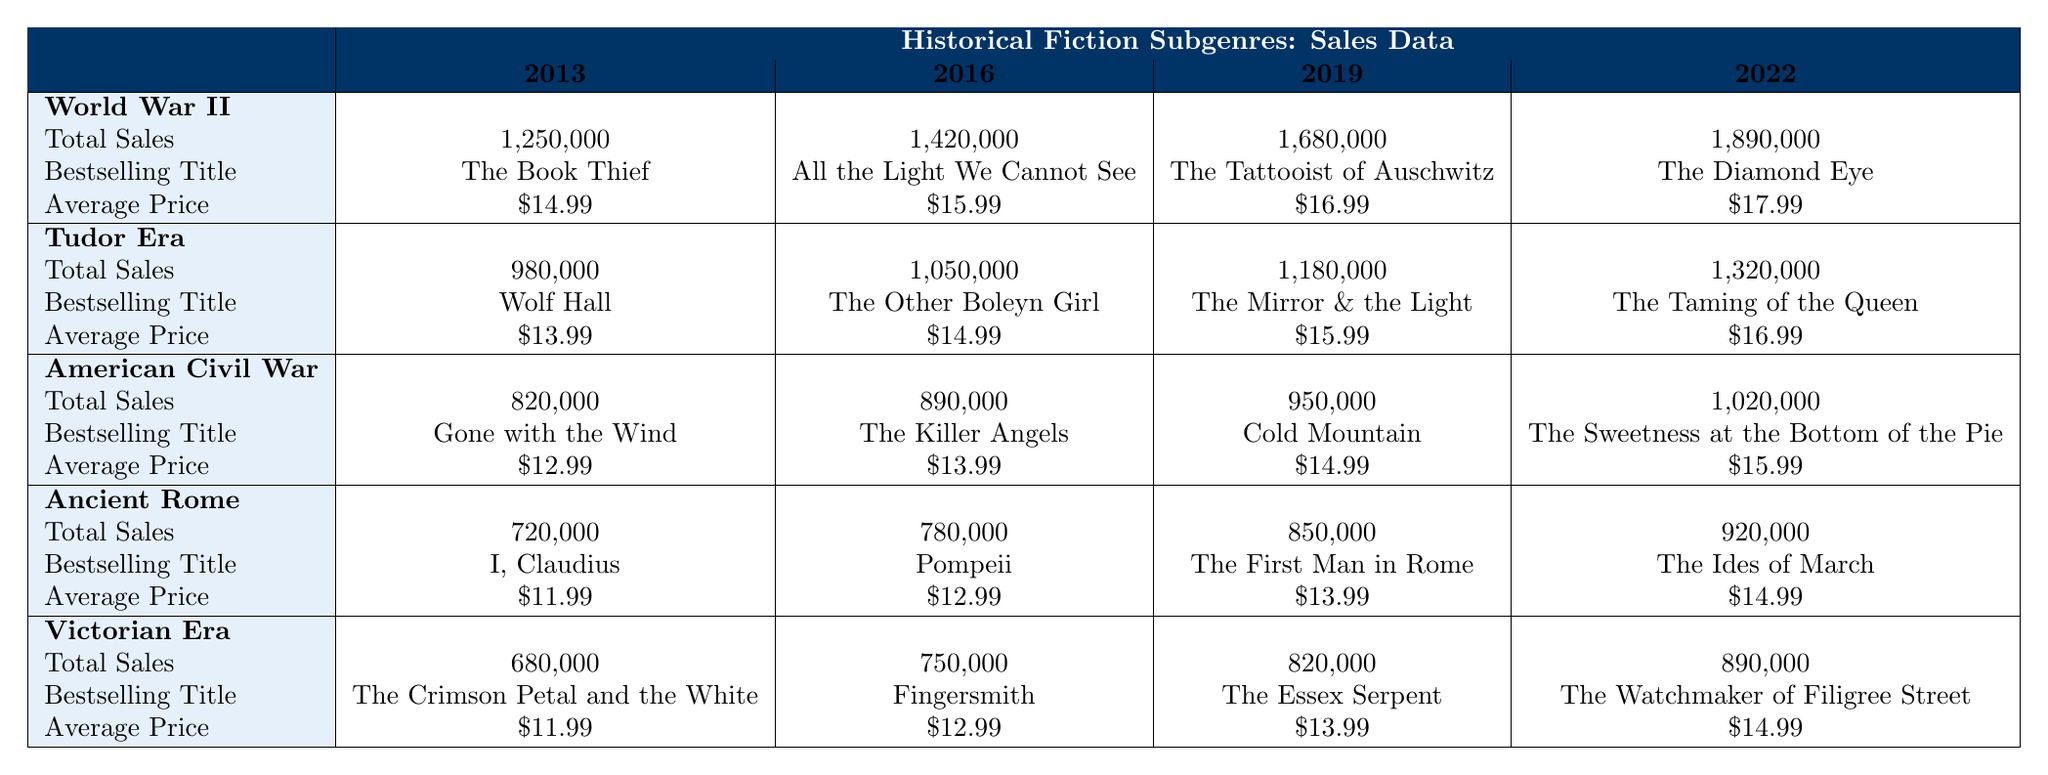What was the bestselling title in the World War II subgenre in 2019? The table indicates that the bestselling title in the World War II subgenre for 2019 is "The Tattooist of Auschwitz."
Answer: The Tattooist of Auschwitz Which historical fiction subgenre had the highest total sales in 2022? In 2022, the World War II subgenre had the highest total sales at 1,890,000, compared to other subgenres.
Answer: World War II What is the average price of books in the Tudor Era subgenre in 2022? According to the table, the average price of books in the Tudor Era subgenre in 2022 is $16.99.
Answer: $16.99 How much did total sales for the American Civil War subgenre increase from 2013 to 2022? The total sales in 2013 were 820,000 and in 2022 were 1,020,000. The increase is calculated as 1,020,000 - 820,000 = 200,000.
Answer: 200,000 What was the average total sales across all subgenres in 2019? The total sales for each subgenre in 2019 were: World War II (1,680,000), Tudor Era (1,180,000), American Civil War (950,000), Ancient Rome (850,000), and Victorian Era (820,000). Summing these gives 5,480,000; dividing by 5 gives an average of 1,096,000.
Answer: 1,096,000 Did any subgenre have a bestselling title listed for all four years? Yes, every subgenre has a bestselling title listed in each year (2013, 2016, 2019, and 2022) in the data provided in the table.
Answer: Yes Which subgenre experienced a decrease in average price from 2013 to 2019? The Ancient Rome subgenre showed a decrease in average price from $11.99 in 2013 to $13.99 in 2019, as seen in the table.
Answer: None What was the total sales difference between the highest and lowest subgenres in 2022? In 2022, World War II had total sales of 1,890,000 and Victorian Era had total sales of 890,000. The difference is 1,890,000 - 890,000 = 1,000,000.
Answer: 1,000,000 For which subgenre did the bestselling title change for every recording year? All subgenres changed their bestselling titles each year from 2013 to 2022 according to the table data presented.
Answer: All subgenres What was the total number of sales for all subgenres combined in 2016? The total sales in 2016 were: World War II (1,420,000), Tudor Era (1,050,000), American Civil War (890,000), Ancient Rome (780,000), and Victorian Era (750,000). Summing these gives 4,890,000.
Answer: 4,890,000 